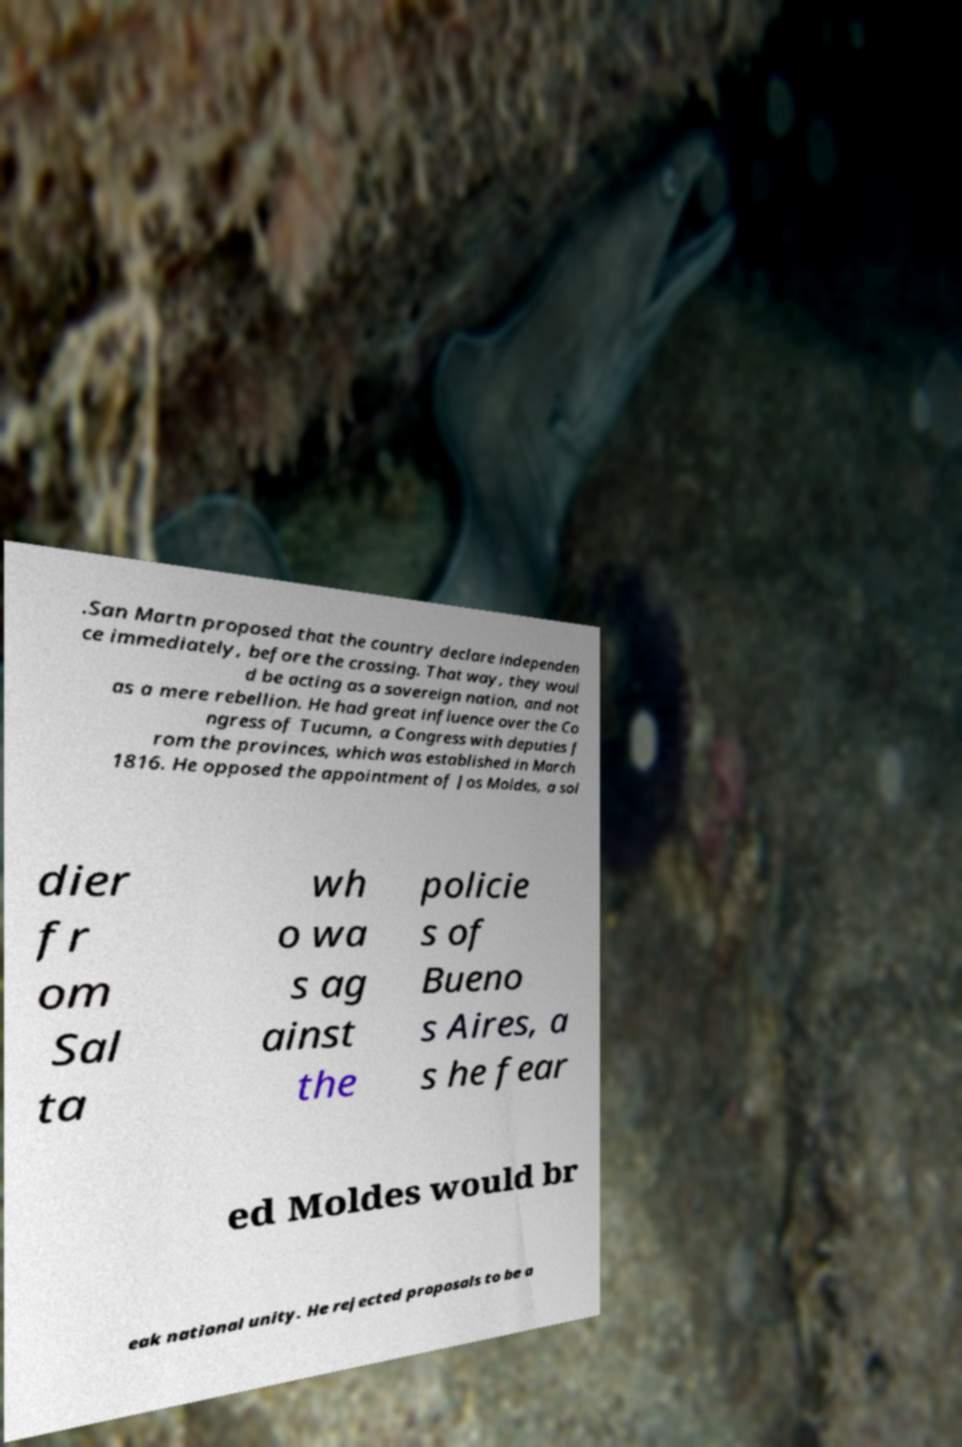I need the written content from this picture converted into text. Can you do that? .San Martn proposed that the country declare independen ce immediately, before the crossing. That way, they woul d be acting as a sovereign nation, and not as a mere rebellion. He had great influence over the Co ngress of Tucumn, a Congress with deputies f rom the provinces, which was established in March 1816. He opposed the appointment of Jos Moldes, a sol dier fr om Sal ta wh o wa s ag ainst the policie s of Bueno s Aires, a s he fear ed Moldes would br eak national unity. He rejected proposals to be a 